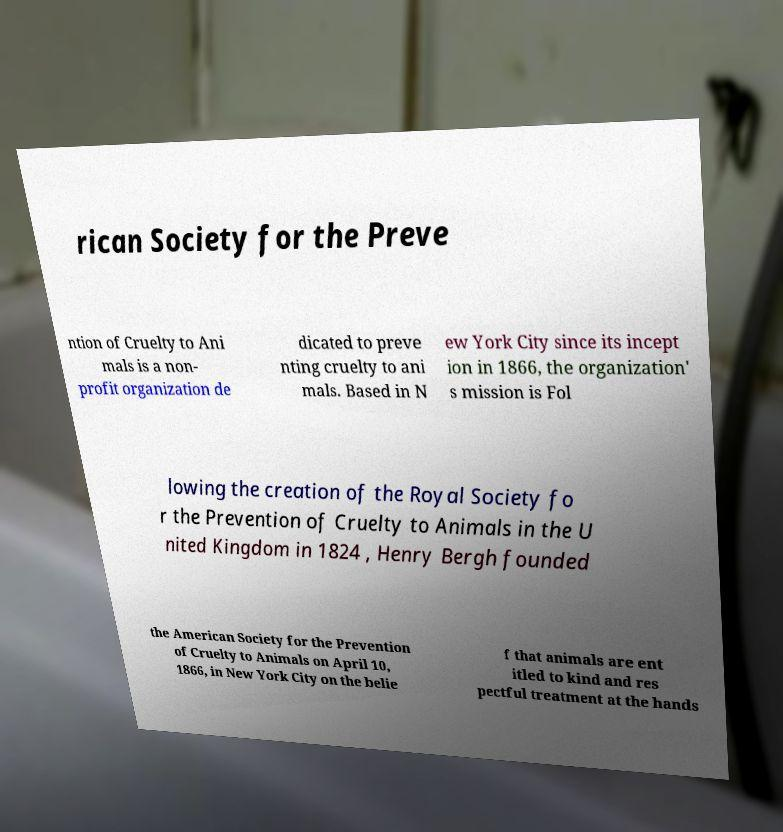Could you extract and type out the text from this image? rican Society for the Preve ntion of Cruelty to Ani mals is a non- profit organization de dicated to preve nting cruelty to ani mals. Based in N ew York City since its incept ion in 1866, the organization' s mission is Fol lowing the creation of the Royal Society fo r the Prevention of Cruelty to Animals in the U nited Kingdom in 1824 , Henry Bergh founded the American Society for the Prevention of Cruelty to Animals on April 10, 1866, in New York City on the belie f that animals are ent itled to kind and res pectful treatment at the hands 